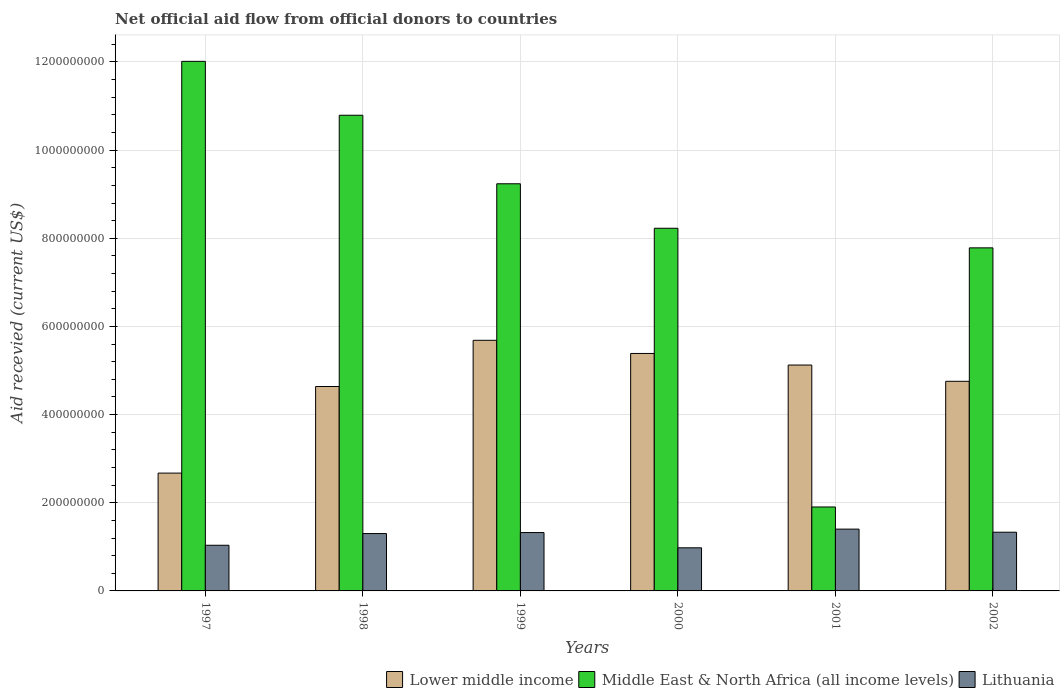How many groups of bars are there?
Provide a short and direct response. 6. In how many cases, is the number of bars for a given year not equal to the number of legend labels?
Offer a very short reply. 0. What is the total aid received in Middle East & North Africa (all income levels) in 2002?
Your answer should be compact. 7.78e+08. Across all years, what is the maximum total aid received in Lower middle income?
Your answer should be compact. 5.69e+08. Across all years, what is the minimum total aid received in Middle East & North Africa (all income levels)?
Keep it short and to the point. 1.90e+08. What is the total total aid received in Lower middle income in the graph?
Provide a short and direct response. 2.83e+09. What is the difference between the total aid received in Middle East & North Africa (all income levels) in 2000 and that in 2002?
Offer a terse response. 4.45e+07. What is the difference between the total aid received in Middle East & North Africa (all income levels) in 2001 and the total aid received in Lithuania in 1999?
Your answer should be compact. 5.81e+07. What is the average total aid received in Middle East & North Africa (all income levels) per year?
Give a very brief answer. 8.33e+08. In the year 1999, what is the difference between the total aid received in Lithuania and total aid received in Lower middle income?
Your response must be concise. -4.36e+08. In how many years, is the total aid received in Middle East & North Africa (all income levels) greater than 320000000 US$?
Give a very brief answer. 5. What is the ratio of the total aid received in Lower middle income in 1999 to that in 2002?
Your answer should be very brief. 1.2. What is the difference between the highest and the second highest total aid received in Middle East & North Africa (all income levels)?
Your response must be concise. 1.22e+08. What is the difference between the highest and the lowest total aid received in Lithuania?
Your answer should be very brief. 4.24e+07. What does the 3rd bar from the left in 2001 represents?
Provide a succinct answer. Lithuania. What does the 3rd bar from the right in 2000 represents?
Offer a terse response. Lower middle income. Is it the case that in every year, the sum of the total aid received in Middle East & North Africa (all income levels) and total aid received in Lithuania is greater than the total aid received in Lower middle income?
Give a very brief answer. No. How many bars are there?
Your response must be concise. 18. Are all the bars in the graph horizontal?
Keep it short and to the point. No. Are the values on the major ticks of Y-axis written in scientific E-notation?
Make the answer very short. No. What is the title of the graph?
Your answer should be compact. Net official aid flow from official donors to countries. Does "El Salvador" appear as one of the legend labels in the graph?
Offer a very short reply. No. What is the label or title of the X-axis?
Your answer should be compact. Years. What is the label or title of the Y-axis?
Provide a short and direct response. Aid recevied (current US$). What is the Aid recevied (current US$) in Lower middle income in 1997?
Provide a short and direct response. 2.67e+08. What is the Aid recevied (current US$) in Middle East & North Africa (all income levels) in 1997?
Offer a very short reply. 1.20e+09. What is the Aid recevied (current US$) of Lithuania in 1997?
Your answer should be compact. 1.04e+08. What is the Aid recevied (current US$) in Lower middle income in 1998?
Your answer should be compact. 4.64e+08. What is the Aid recevied (current US$) in Middle East & North Africa (all income levels) in 1998?
Give a very brief answer. 1.08e+09. What is the Aid recevied (current US$) in Lithuania in 1998?
Your answer should be very brief. 1.30e+08. What is the Aid recevied (current US$) of Lower middle income in 1999?
Make the answer very short. 5.69e+08. What is the Aid recevied (current US$) of Middle East & North Africa (all income levels) in 1999?
Offer a terse response. 9.24e+08. What is the Aid recevied (current US$) in Lithuania in 1999?
Your response must be concise. 1.32e+08. What is the Aid recevied (current US$) of Lower middle income in 2000?
Give a very brief answer. 5.39e+08. What is the Aid recevied (current US$) in Middle East & North Africa (all income levels) in 2000?
Offer a terse response. 8.23e+08. What is the Aid recevied (current US$) in Lithuania in 2000?
Provide a succinct answer. 9.78e+07. What is the Aid recevied (current US$) in Lower middle income in 2001?
Give a very brief answer. 5.12e+08. What is the Aid recevied (current US$) in Middle East & North Africa (all income levels) in 2001?
Ensure brevity in your answer.  1.90e+08. What is the Aid recevied (current US$) in Lithuania in 2001?
Your answer should be compact. 1.40e+08. What is the Aid recevied (current US$) of Lower middle income in 2002?
Give a very brief answer. 4.76e+08. What is the Aid recevied (current US$) of Middle East & North Africa (all income levels) in 2002?
Your response must be concise. 7.78e+08. What is the Aid recevied (current US$) in Lithuania in 2002?
Offer a very short reply. 1.33e+08. Across all years, what is the maximum Aid recevied (current US$) of Lower middle income?
Offer a terse response. 5.69e+08. Across all years, what is the maximum Aid recevied (current US$) of Middle East & North Africa (all income levels)?
Ensure brevity in your answer.  1.20e+09. Across all years, what is the maximum Aid recevied (current US$) of Lithuania?
Make the answer very short. 1.40e+08. Across all years, what is the minimum Aid recevied (current US$) in Lower middle income?
Your response must be concise. 2.67e+08. Across all years, what is the minimum Aid recevied (current US$) of Middle East & North Africa (all income levels)?
Provide a succinct answer. 1.90e+08. Across all years, what is the minimum Aid recevied (current US$) of Lithuania?
Your response must be concise. 9.78e+07. What is the total Aid recevied (current US$) in Lower middle income in the graph?
Your response must be concise. 2.83e+09. What is the total Aid recevied (current US$) in Middle East & North Africa (all income levels) in the graph?
Ensure brevity in your answer.  5.00e+09. What is the total Aid recevied (current US$) of Lithuania in the graph?
Provide a short and direct response. 7.37e+08. What is the difference between the Aid recevied (current US$) of Lower middle income in 1997 and that in 1998?
Your response must be concise. -1.96e+08. What is the difference between the Aid recevied (current US$) of Middle East & North Africa (all income levels) in 1997 and that in 1998?
Your answer should be very brief. 1.22e+08. What is the difference between the Aid recevied (current US$) in Lithuania in 1997 and that in 1998?
Give a very brief answer. -2.66e+07. What is the difference between the Aid recevied (current US$) in Lower middle income in 1997 and that in 1999?
Offer a very short reply. -3.01e+08. What is the difference between the Aid recevied (current US$) of Middle East & North Africa (all income levels) in 1997 and that in 1999?
Ensure brevity in your answer.  2.78e+08. What is the difference between the Aid recevied (current US$) of Lithuania in 1997 and that in 1999?
Your answer should be compact. -2.88e+07. What is the difference between the Aid recevied (current US$) of Lower middle income in 1997 and that in 2000?
Ensure brevity in your answer.  -2.71e+08. What is the difference between the Aid recevied (current US$) of Middle East & North Africa (all income levels) in 1997 and that in 2000?
Ensure brevity in your answer.  3.79e+08. What is the difference between the Aid recevied (current US$) in Lithuania in 1997 and that in 2000?
Provide a succinct answer. 5.76e+06. What is the difference between the Aid recevied (current US$) of Lower middle income in 1997 and that in 2001?
Your response must be concise. -2.45e+08. What is the difference between the Aid recevied (current US$) of Middle East & North Africa (all income levels) in 1997 and that in 2001?
Offer a very short reply. 1.01e+09. What is the difference between the Aid recevied (current US$) in Lithuania in 1997 and that in 2001?
Make the answer very short. -3.66e+07. What is the difference between the Aid recevied (current US$) of Lower middle income in 1997 and that in 2002?
Give a very brief answer. -2.08e+08. What is the difference between the Aid recevied (current US$) of Middle East & North Africa (all income levels) in 1997 and that in 2002?
Your answer should be very brief. 4.23e+08. What is the difference between the Aid recevied (current US$) in Lithuania in 1997 and that in 2002?
Your answer should be very brief. -2.96e+07. What is the difference between the Aid recevied (current US$) in Lower middle income in 1998 and that in 1999?
Make the answer very short. -1.05e+08. What is the difference between the Aid recevied (current US$) of Middle East & North Africa (all income levels) in 1998 and that in 1999?
Keep it short and to the point. 1.55e+08. What is the difference between the Aid recevied (current US$) in Lithuania in 1998 and that in 1999?
Your response must be concise. -2.27e+06. What is the difference between the Aid recevied (current US$) in Lower middle income in 1998 and that in 2000?
Keep it short and to the point. -7.50e+07. What is the difference between the Aid recevied (current US$) of Middle East & North Africa (all income levels) in 1998 and that in 2000?
Your answer should be very brief. 2.56e+08. What is the difference between the Aid recevied (current US$) of Lithuania in 1998 and that in 2000?
Make the answer very short. 3.23e+07. What is the difference between the Aid recevied (current US$) in Lower middle income in 1998 and that in 2001?
Provide a short and direct response. -4.87e+07. What is the difference between the Aid recevied (current US$) in Middle East & North Africa (all income levels) in 1998 and that in 2001?
Give a very brief answer. 8.89e+08. What is the difference between the Aid recevied (current US$) of Lithuania in 1998 and that in 2001?
Keep it short and to the point. -1.01e+07. What is the difference between the Aid recevied (current US$) in Lower middle income in 1998 and that in 2002?
Your response must be concise. -1.18e+07. What is the difference between the Aid recevied (current US$) in Middle East & North Africa (all income levels) in 1998 and that in 2002?
Provide a succinct answer. 3.01e+08. What is the difference between the Aid recevied (current US$) of Lithuania in 1998 and that in 2002?
Keep it short and to the point. -3.08e+06. What is the difference between the Aid recevied (current US$) in Lower middle income in 1999 and that in 2000?
Make the answer very short. 2.98e+07. What is the difference between the Aid recevied (current US$) of Middle East & North Africa (all income levels) in 1999 and that in 2000?
Your response must be concise. 1.01e+08. What is the difference between the Aid recevied (current US$) of Lithuania in 1999 and that in 2000?
Ensure brevity in your answer.  3.46e+07. What is the difference between the Aid recevied (current US$) of Lower middle income in 1999 and that in 2001?
Make the answer very short. 5.61e+07. What is the difference between the Aid recevied (current US$) in Middle East & North Africa (all income levels) in 1999 and that in 2001?
Provide a succinct answer. 7.33e+08. What is the difference between the Aid recevied (current US$) of Lithuania in 1999 and that in 2001?
Provide a short and direct response. -7.83e+06. What is the difference between the Aid recevied (current US$) of Lower middle income in 1999 and that in 2002?
Provide a short and direct response. 9.30e+07. What is the difference between the Aid recevied (current US$) in Middle East & North Africa (all income levels) in 1999 and that in 2002?
Make the answer very short. 1.45e+08. What is the difference between the Aid recevied (current US$) of Lithuania in 1999 and that in 2002?
Your response must be concise. -8.10e+05. What is the difference between the Aid recevied (current US$) of Lower middle income in 2000 and that in 2001?
Give a very brief answer. 2.62e+07. What is the difference between the Aid recevied (current US$) of Middle East & North Africa (all income levels) in 2000 and that in 2001?
Your answer should be very brief. 6.32e+08. What is the difference between the Aid recevied (current US$) of Lithuania in 2000 and that in 2001?
Provide a succinct answer. -4.24e+07. What is the difference between the Aid recevied (current US$) of Lower middle income in 2000 and that in 2002?
Keep it short and to the point. 6.32e+07. What is the difference between the Aid recevied (current US$) in Middle East & North Africa (all income levels) in 2000 and that in 2002?
Offer a terse response. 4.45e+07. What is the difference between the Aid recevied (current US$) in Lithuania in 2000 and that in 2002?
Make the answer very short. -3.54e+07. What is the difference between the Aid recevied (current US$) of Lower middle income in 2001 and that in 2002?
Make the answer very short. 3.69e+07. What is the difference between the Aid recevied (current US$) in Middle East & North Africa (all income levels) in 2001 and that in 2002?
Make the answer very short. -5.88e+08. What is the difference between the Aid recevied (current US$) of Lithuania in 2001 and that in 2002?
Your answer should be very brief. 7.02e+06. What is the difference between the Aid recevied (current US$) of Lower middle income in 1997 and the Aid recevied (current US$) of Middle East & North Africa (all income levels) in 1998?
Ensure brevity in your answer.  -8.12e+08. What is the difference between the Aid recevied (current US$) of Lower middle income in 1997 and the Aid recevied (current US$) of Lithuania in 1998?
Keep it short and to the point. 1.37e+08. What is the difference between the Aid recevied (current US$) of Middle East & North Africa (all income levels) in 1997 and the Aid recevied (current US$) of Lithuania in 1998?
Provide a succinct answer. 1.07e+09. What is the difference between the Aid recevied (current US$) of Lower middle income in 1997 and the Aid recevied (current US$) of Middle East & North Africa (all income levels) in 1999?
Make the answer very short. -6.56e+08. What is the difference between the Aid recevied (current US$) of Lower middle income in 1997 and the Aid recevied (current US$) of Lithuania in 1999?
Provide a succinct answer. 1.35e+08. What is the difference between the Aid recevied (current US$) in Middle East & North Africa (all income levels) in 1997 and the Aid recevied (current US$) in Lithuania in 1999?
Ensure brevity in your answer.  1.07e+09. What is the difference between the Aid recevied (current US$) of Lower middle income in 1997 and the Aid recevied (current US$) of Middle East & North Africa (all income levels) in 2000?
Your answer should be compact. -5.55e+08. What is the difference between the Aid recevied (current US$) of Lower middle income in 1997 and the Aid recevied (current US$) of Lithuania in 2000?
Your answer should be compact. 1.69e+08. What is the difference between the Aid recevied (current US$) in Middle East & North Africa (all income levels) in 1997 and the Aid recevied (current US$) in Lithuania in 2000?
Keep it short and to the point. 1.10e+09. What is the difference between the Aid recevied (current US$) of Lower middle income in 1997 and the Aid recevied (current US$) of Middle East & North Africa (all income levels) in 2001?
Your response must be concise. 7.68e+07. What is the difference between the Aid recevied (current US$) in Lower middle income in 1997 and the Aid recevied (current US$) in Lithuania in 2001?
Your answer should be very brief. 1.27e+08. What is the difference between the Aid recevied (current US$) of Middle East & North Africa (all income levels) in 1997 and the Aid recevied (current US$) of Lithuania in 2001?
Offer a terse response. 1.06e+09. What is the difference between the Aid recevied (current US$) of Lower middle income in 1997 and the Aid recevied (current US$) of Middle East & North Africa (all income levels) in 2002?
Give a very brief answer. -5.11e+08. What is the difference between the Aid recevied (current US$) of Lower middle income in 1997 and the Aid recevied (current US$) of Lithuania in 2002?
Make the answer very short. 1.34e+08. What is the difference between the Aid recevied (current US$) in Middle East & North Africa (all income levels) in 1997 and the Aid recevied (current US$) in Lithuania in 2002?
Offer a terse response. 1.07e+09. What is the difference between the Aid recevied (current US$) of Lower middle income in 1998 and the Aid recevied (current US$) of Middle East & North Africa (all income levels) in 1999?
Offer a very short reply. -4.60e+08. What is the difference between the Aid recevied (current US$) in Lower middle income in 1998 and the Aid recevied (current US$) in Lithuania in 1999?
Keep it short and to the point. 3.31e+08. What is the difference between the Aid recevied (current US$) of Middle East & North Africa (all income levels) in 1998 and the Aid recevied (current US$) of Lithuania in 1999?
Ensure brevity in your answer.  9.47e+08. What is the difference between the Aid recevied (current US$) in Lower middle income in 1998 and the Aid recevied (current US$) in Middle East & North Africa (all income levels) in 2000?
Provide a succinct answer. -3.59e+08. What is the difference between the Aid recevied (current US$) of Lower middle income in 1998 and the Aid recevied (current US$) of Lithuania in 2000?
Offer a terse response. 3.66e+08. What is the difference between the Aid recevied (current US$) in Middle East & North Africa (all income levels) in 1998 and the Aid recevied (current US$) in Lithuania in 2000?
Your answer should be very brief. 9.81e+08. What is the difference between the Aid recevied (current US$) of Lower middle income in 1998 and the Aid recevied (current US$) of Middle East & North Africa (all income levels) in 2001?
Your answer should be very brief. 2.73e+08. What is the difference between the Aid recevied (current US$) of Lower middle income in 1998 and the Aid recevied (current US$) of Lithuania in 2001?
Keep it short and to the point. 3.24e+08. What is the difference between the Aid recevied (current US$) of Middle East & North Africa (all income levels) in 1998 and the Aid recevied (current US$) of Lithuania in 2001?
Make the answer very short. 9.39e+08. What is the difference between the Aid recevied (current US$) of Lower middle income in 1998 and the Aid recevied (current US$) of Middle East & North Africa (all income levels) in 2002?
Offer a terse response. -3.15e+08. What is the difference between the Aid recevied (current US$) in Lower middle income in 1998 and the Aid recevied (current US$) in Lithuania in 2002?
Your response must be concise. 3.31e+08. What is the difference between the Aid recevied (current US$) in Middle East & North Africa (all income levels) in 1998 and the Aid recevied (current US$) in Lithuania in 2002?
Make the answer very short. 9.46e+08. What is the difference between the Aid recevied (current US$) in Lower middle income in 1999 and the Aid recevied (current US$) in Middle East & North Africa (all income levels) in 2000?
Ensure brevity in your answer.  -2.54e+08. What is the difference between the Aid recevied (current US$) of Lower middle income in 1999 and the Aid recevied (current US$) of Lithuania in 2000?
Offer a terse response. 4.71e+08. What is the difference between the Aid recevied (current US$) in Middle East & North Africa (all income levels) in 1999 and the Aid recevied (current US$) in Lithuania in 2000?
Give a very brief answer. 8.26e+08. What is the difference between the Aid recevied (current US$) of Lower middle income in 1999 and the Aid recevied (current US$) of Middle East & North Africa (all income levels) in 2001?
Make the answer very short. 3.78e+08. What is the difference between the Aid recevied (current US$) in Lower middle income in 1999 and the Aid recevied (current US$) in Lithuania in 2001?
Your answer should be compact. 4.28e+08. What is the difference between the Aid recevied (current US$) of Middle East & North Africa (all income levels) in 1999 and the Aid recevied (current US$) of Lithuania in 2001?
Provide a succinct answer. 7.83e+08. What is the difference between the Aid recevied (current US$) of Lower middle income in 1999 and the Aid recevied (current US$) of Middle East & North Africa (all income levels) in 2002?
Give a very brief answer. -2.10e+08. What is the difference between the Aid recevied (current US$) in Lower middle income in 1999 and the Aid recevied (current US$) in Lithuania in 2002?
Offer a very short reply. 4.35e+08. What is the difference between the Aid recevied (current US$) in Middle East & North Africa (all income levels) in 1999 and the Aid recevied (current US$) in Lithuania in 2002?
Keep it short and to the point. 7.90e+08. What is the difference between the Aid recevied (current US$) in Lower middle income in 2000 and the Aid recevied (current US$) in Middle East & North Africa (all income levels) in 2001?
Provide a succinct answer. 3.48e+08. What is the difference between the Aid recevied (current US$) in Lower middle income in 2000 and the Aid recevied (current US$) in Lithuania in 2001?
Your answer should be compact. 3.98e+08. What is the difference between the Aid recevied (current US$) in Middle East & North Africa (all income levels) in 2000 and the Aid recevied (current US$) in Lithuania in 2001?
Keep it short and to the point. 6.83e+08. What is the difference between the Aid recevied (current US$) in Lower middle income in 2000 and the Aid recevied (current US$) in Middle East & North Africa (all income levels) in 2002?
Make the answer very short. -2.40e+08. What is the difference between the Aid recevied (current US$) of Lower middle income in 2000 and the Aid recevied (current US$) of Lithuania in 2002?
Provide a succinct answer. 4.06e+08. What is the difference between the Aid recevied (current US$) in Middle East & North Africa (all income levels) in 2000 and the Aid recevied (current US$) in Lithuania in 2002?
Your answer should be very brief. 6.90e+08. What is the difference between the Aid recevied (current US$) in Lower middle income in 2001 and the Aid recevied (current US$) in Middle East & North Africa (all income levels) in 2002?
Make the answer very short. -2.66e+08. What is the difference between the Aid recevied (current US$) of Lower middle income in 2001 and the Aid recevied (current US$) of Lithuania in 2002?
Make the answer very short. 3.79e+08. What is the difference between the Aid recevied (current US$) in Middle East & North Africa (all income levels) in 2001 and the Aid recevied (current US$) in Lithuania in 2002?
Provide a short and direct response. 5.72e+07. What is the average Aid recevied (current US$) in Lower middle income per year?
Provide a succinct answer. 4.71e+08. What is the average Aid recevied (current US$) in Middle East & North Africa (all income levels) per year?
Your response must be concise. 8.33e+08. What is the average Aid recevied (current US$) in Lithuania per year?
Give a very brief answer. 1.23e+08. In the year 1997, what is the difference between the Aid recevied (current US$) in Lower middle income and Aid recevied (current US$) in Middle East & North Africa (all income levels)?
Offer a very short reply. -9.34e+08. In the year 1997, what is the difference between the Aid recevied (current US$) in Lower middle income and Aid recevied (current US$) in Lithuania?
Your response must be concise. 1.64e+08. In the year 1997, what is the difference between the Aid recevied (current US$) of Middle East & North Africa (all income levels) and Aid recevied (current US$) of Lithuania?
Keep it short and to the point. 1.10e+09. In the year 1998, what is the difference between the Aid recevied (current US$) of Lower middle income and Aid recevied (current US$) of Middle East & North Africa (all income levels)?
Ensure brevity in your answer.  -6.15e+08. In the year 1998, what is the difference between the Aid recevied (current US$) of Lower middle income and Aid recevied (current US$) of Lithuania?
Make the answer very short. 3.34e+08. In the year 1998, what is the difference between the Aid recevied (current US$) of Middle East & North Africa (all income levels) and Aid recevied (current US$) of Lithuania?
Provide a short and direct response. 9.49e+08. In the year 1999, what is the difference between the Aid recevied (current US$) of Lower middle income and Aid recevied (current US$) of Middle East & North Africa (all income levels)?
Your answer should be very brief. -3.55e+08. In the year 1999, what is the difference between the Aid recevied (current US$) in Lower middle income and Aid recevied (current US$) in Lithuania?
Provide a short and direct response. 4.36e+08. In the year 1999, what is the difference between the Aid recevied (current US$) in Middle East & North Africa (all income levels) and Aid recevied (current US$) in Lithuania?
Your response must be concise. 7.91e+08. In the year 2000, what is the difference between the Aid recevied (current US$) in Lower middle income and Aid recevied (current US$) in Middle East & North Africa (all income levels)?
Your answer should be very brief. -2.84e+08. In the year 2000, what is the difference between the Aid recevied (current US$) in Lower middle income and Aid recevied (current US$) in Lithuania?
Provide a short and direct response. 4.41e+08. In the year 2000, what is the difference between the Aid recevied (current US$) of Middle East & North Africa (all income levels) and Aid recevied (current US$) of Lithuania?
Your answer should be compact. 7.25e+08. In the year 2001, what is the difference between the Aid recevied (current US$) of Lower middle income and Aid recevied (current US$) of Middle East & North Africa (all income levels)?
Give a very brief answer. 3.22e+08. In the year 2001, what is the difference between the Aid recevied (current US$) of Lower middle income and Aid recevied (current US$) of Lithuania?
Ensure brevity in your answer.  3.72e+08. In the year 2001, what is the difference between the Aid recevied (current US$) in Middle East & North Africa (all income levels) and Aid recevied (current US$) in Lithuania?
Give a very brief answer. 5.02e+07. In the year 2002, what is the difference between the Aid recevied (current US$) of Lower middle income and Aid recevied (current US$) of Middle East & North Africa (all income levels)?
Your answer should be very brief. -3.03e+08. In the year 2002, what is the difference between the Aid recevied (current US$) of Lower middle income and Aid recevied (current US$) of Lithuania?
Provide a short and direct response. 3.42e+08. In the year 2002, what is the difference between the Aid recevied (current US$) in Middle East & North Africa (all income levels) and Aid recevied (current US$) in Lithuania?
Provide a succinct answer. 6.45e+08. What is the ratio of the Aid recevied (current US$) in Lower middle income in 1997 to that in 1998?
Provide a short and direct response. 0.58. What is the ratio of the Aid recevied (current US$) in Middle East & North Africa (all income levels) in 1997 to that in 1998?
Offer a terse response. 1.11. What is the ratio of the Aid recevied (current US$) of Lithuania in 1997 to that in 1998?
Keep it short and to the point. 0.8. What is the ratio of the Aid recevied (current US$) of Lower middle income in 1997 to that in 1999?
Your answer should be compact. 0.47. What is the ratio of the Aid recevied (current US$) in Middle East & North Africa (all income levels) in 1997 to that in 1999?
Offer a terse response. 1.3. What is the ratio of the Aid recevied (current US$) of Lithuania in 1997 to that in 1999?
Ensure brevity in your answer.  0.78. What is the ratio of the Aid recevied (current US$) in Lower middle income in 1997 to that in 2000?
Offer a terse response. 0.5. What is the ratio of the Aid recevied (current US$) in Middle East & North Africa (all income levels) in 1997 to that in 2000?
Offer a terse response. 1.46. What is the ratio of the Aid recevied (current US$) in Lithuania in 1997 to that in 2000?
Keep it short and to the point. 1.06. What is the ratio of the Aid recevied (current US$) of Lower middle income in 1997 to that in 2001?
Make the answer very short. 0.52. What is the ratio of the Aid recevied (current US$) in Middle East & North Africa (all income levels) in 1997 to that in 2001?
Your response must be concise. 6.31. What is the ratio of the Aid recevied (current US$) of Lithuania in 1997 to that in 2001?
Give a very brief answer. 0.74. What is the ratio of the Aid recevied (current US$) in Lower middle income in 1997 to that in 2002?
Provide a succinct answer. 0.56. What is the ratio of the Aid recevied (current US$) of Middle East & North Africa (all income levels) in 1997 to that in 2002?
Provide a short and direct response. 1.54. What is the ratio of the Aid recevied (current US$) in Lithuania in 1997 to that in 2002?
Give a very brief answer. 0.78. What is the ratio of the Aid recevied (current US$) in Lower middle income in 1998 to that in 1999?
Your answer should be compact. 0.82. What is the ratio of the Aid recevied (current US$) of Middle East & North Africa (all income levels) in 1998 to that in 1999?
Offer a terse response. 1.17. What is the ratio of the Aid recevied (current US$) in Lithuania in 1998 to that in 1999?
Offer a very short reply. 0.98. What is the ratio of the Aid recevied (current US$) of Lower middle income in 1998 to that in 2000?
Your answer should be very brief. 0.86. What is the ratio of the Aid recevied (current US$) of Middle East & North Africa (all income levels) in 1998 to that in 2000?
Keep it short and to the point. 1.31. What is the ratio of the Aid recevied (current US$) of Lithuania in 1998 to that in 2000?
Make the answer very short. 1.33. What is the ratio of the Aid recevied (current US$) in Lower middle income in 1998 to that in 2001?
Offer a very short reply. 0.91. What is the ratio of the Aid recevied (current US$) in Middle East & North Africa (all income levels) in 1998 to that in 2001?
Offer a terse response. 5.67. What is the ratio of the Aid recevied (current US$) of Lithuania in 1998 to that in 2001?
Provide a succinct answer. 0.93. What is the ratio of the Aid recevied (current US$) in Lower middle income in 1998 to that in 2002?
Provide a succinct answer. 0.98. What is the ratio of the Aid recevied (current US$) in Middle East & North Africa (all income levels) in 1998 to that in 2002?
Provide a succinct answer. 1.39. What is the ratio of the Aid recevied (current US$) in Lithuania in 1998 to that in 2002?
Your answer should be very brief. 0.98. What is the ratio of the Aid recevied (current US$) of Lower middle income in 1999 to that in 2000?
Make the answer very short. 1.06. What is the ratio of the Aid recevied (current US$) in Middle East & North Africa (all income levels) in 1999 to that in 2000?
Keep it short and to the point. 1.12. What is the ratio of the Aid recevied (current US$) of Lithuania in 1999 to that in 2000?
Provide a short and direct response. 1.35. What is the ratio of the Aid recevied (current US$) of Lower middle income in 1999 to that in 2001?
Give a very brief answer. 1.11. What is the ratio of the Aid recevied (current US$) of Middle East & North Africa (all income levels) in 1999 to that in 2001?
Keep it short and to the point. 4.85. What is the ratio of the Aid recevied (current US$) in Lithuania in 1999 to that in 2001?
Your answer should be compact. 0.94. What is the ratio of the Aid recevied (current US$) in Lower middle income in 1999 to that in 2002?
Give a very brief answer. 1.2. What is the ratio of the Aid recevied (current US$) in Middle East & North Africa (all income levels) in 1999 to that in 2002?
Offer a terse response. 1.19. What is the ratio of the Aid recevied (current US$) of Lithuania in 1999 to that in 2002?
Offer a terse response. 0.99. What is the ratio of the Aid recevied (current US$) of Lower middle income in 2000 to that in 2001?
Your answer should be compact. 1.05. What is the ratio of the Aid recevied (current US$) in Middle East & North Africa (all income levels) in 2000 to that in 2001?
Your response must be concise. 4.32. What is the ratio of the Aid recevied (current US$) in Lithuania in 2000 to that in 2001?
Provide a short and direct response. 0.7. What is the ratio of the Aid recevied (current US$) in Lower middle income in 2000 to that in 2002?
Make the answer very short. 1.13. What is the ratio of the Aid recevied (current US$) in Middle East & North Africa (all income levels) in 2000 to that in 2002?
Give a very brief answer. 1.06. What is the ratio of the Aid recevied (current US$) in Lithuania in 2000 to that in 2002?
Give a very brief answer. 0.73. What is the ratio of the Aid recevied (current US$) of Lower middle income in 2001 to that in 2002?
Offer a terse response. 1.08. What is the ratio of the Aid recevied (current US$) of Middle East & North Africa (all income levels) in 2001 to that in 2002?
Keep it short and to the point. 0.24. What is the ratio of the Aid recevied (current US$) of Lithuania in 2001 to that in 2002?
Ensure brevity in your answer.  1.05. What is the difference between the highest and the second highest Aid recevied (current US$) of Lower middle income?
Provide a succinct answer. 2.98e+07. What is the difference between the highest and the second highest Aid recevied (current US$) of Middle East & North Africa (all income levels)?
Give a very brief answer. 1.22e+08. What is the difference between the highest and the second highest Aid recevied (current US$) of Lithuania?
Offer a terse response. 7.02e+06. What is the difference between the highest and the lowest Aid recevied (current US$) of Lower middle income?
Provide a short and direct response. 3.01e+08. What is the difference between the highest and the lowest Aid recevied (current US$) of Middle East & North Africa (all income levels)?
Provide a succinct answer. 1.01e+09. What is the difference between the highest and the lowest Aid recevied (current US$) in Lithuania?
Provide a succinct answer. 4.24e+07. 